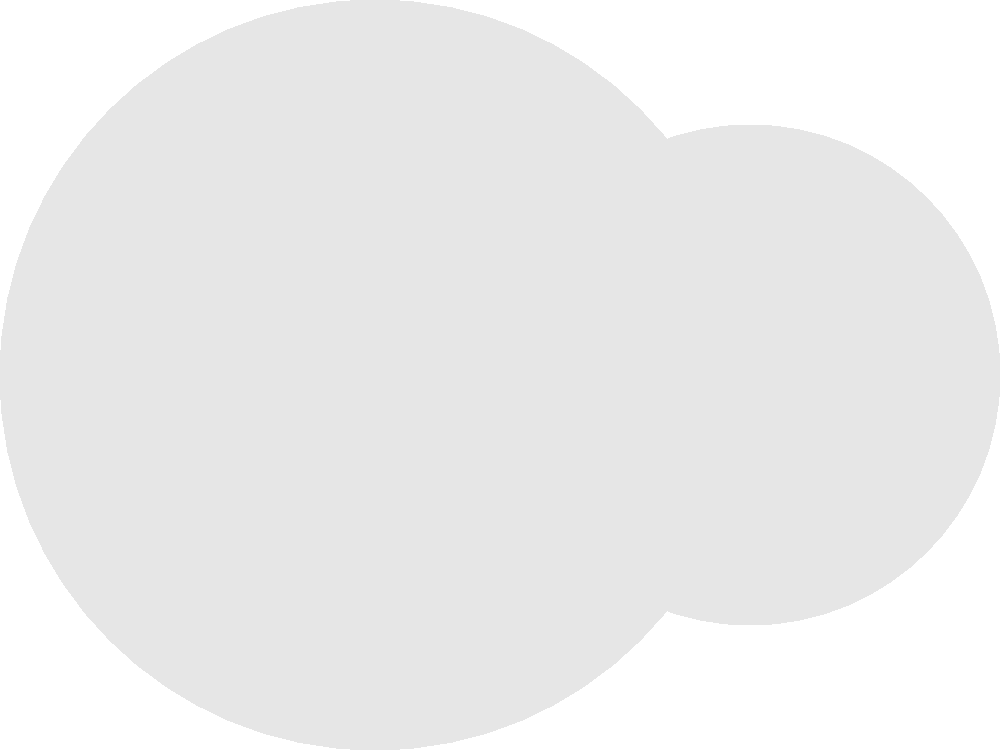Using computer-aided design software, calculate the area of the shaded region formed by two overlapping circles with centers $O_1$ and $O_2$. The radius of circle $O_1$ is 1.5 units, and the radius of circle $O_2$ is 1 unit. The distance between the centers is 1.5 units. Round your answer to two decimal places. To solve this problem efficiently using computer-aided design software, we can follow these steps:

1. Calculate the total area of both circles:
   $$A_1 = \pi r_1^2 = \pi (1.5)^2 = 2.25\pi$$
   $$A_2 = \pi r_2^2 = \pi (1)^2 = \pi$$
   $$A_{total} = A_1 + A_2 = 3.25\pi$$

2. Calculate the area of the overlapping region using the formula for the area of intersection of two circles:
   $$A_{overlap} = r_1^2 \arccos(\frac{d^2 + r_1^2 - r_2^2}{2dr_1}) + r_2^2 \arccos(\frac{d^2 + r_2^2 - r_1^2}{2dr_2}) - \frac{1}{2}\sqrt{(-d+r_1+r_2)(d+r_1-r_2)(d-r_1+r_2)(d+r_1+r_2)}$$
   
   Where $d$ is the distance between centers, $r_1$ and $r_2$ are the radii.

3. Use a computer algebra system or programming language to evaluate this expression:
   $$A_{overlap} \approx 0.7544$$

4. Calculate the shaded area by subtracting the overlap from the total area:
   $$A_{shaded} = A_{total} - A_{overlap}$$
   $$A_{shaded} = 3.25\pi - 0.7544$$
   $$A_{shaded} \approx 9.4580$$

5. Round the result to two decimal places:
   $$A_{shaded} \approx 9.46$$

Using technology allows for quick and accurate calculations, especially for complex formulas like the area of intersection between circles.
Answer: 9.46 square units 